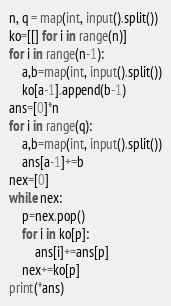<code> <loc_0><loc_0><loc_500><loc_500><_Python_>n, q = map(int, input().split())
ko=[[] for i in range(n)]
for i in range(n-1):
    a,b=map(int, input().split())
    ko[a-1].append(b-1)
ans=[0]*n
for i in range(q):
    a,b=map(int, input().split())
    ans[a-1]+=b
nex=[0]
while nex:
    p=nex.pop()
    for i in ko[p]:
        ans[i]+=ans[p]
    nex+=ko[p]
print(*ans)
</code> 